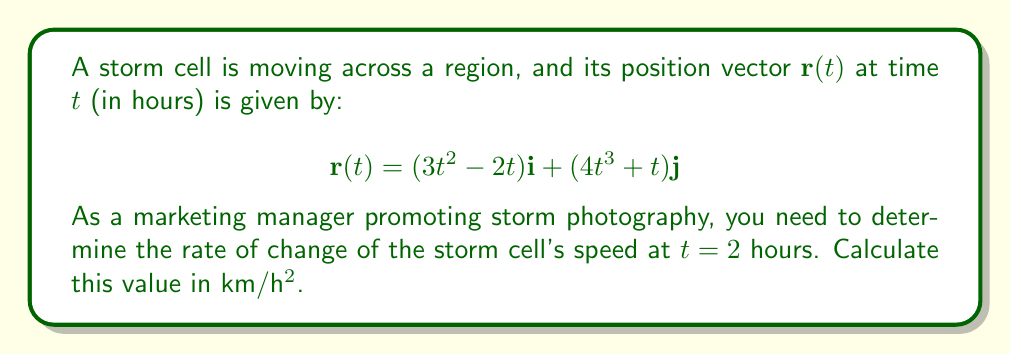Can you answer this question? To solve this problem, we'll follow these steps:

1) First, we need to find the velocity vector $\mathbf{v}(t)$ by differentiating $\mathbf{r}(t)$ with respect to $t$:

   $$\mathbf{v}(t) = \frac{d\mathbf{r}}{dt} = (6t - 2)\mathbf{i} + (12t^2 + 1)\mathbf{j}$$

2) The speed of the storm cell is the magnitude of the velocity vector:

   $$s(t) = \|\mathbf{v}(t)\| = \sqrt{(6t - 2)^2 + (12t^2 + 1)^2}$$

3) To find the rate of change of speed, we need to differentiate $s(t)$ with respect to $t$:

   $$\frac{ds}{dt} = \frac{d}{dt}\sqrt{(6t - 2)^2 + (12t^2 + 1)^2}$$

4) Using the chain rule:

   $$\frac{ds}{dt} = \frac{1}{2\sqrt{(6t - 2)^2 + (12t^2 + 1)^2}} \cdot \frac{d}{dt}[(6t - 2)^2 + (12t^2 + 1)^2]$$

5) Differentiating the inside:

   $$\frac{ds}{dt} = \frac{2(6t - 2)(6) + 2(12t^2 + 1)(24t)}{2\sqrt{(6t - 2)^2 + (12t^2 + 1)^2}}$$

6) Simplifying:

   $$\frac{ds}{dt} = \frac{12(6t - 2) + 48t(12t^2 + 1)}{2\sqrt{(6t - 2)^2 + (12t^2 + 1)^2}}$$

7) Now, we evaluate this at $t = 2$:

   $$\left.\frac{ds}{dt}\right|_{t=2} = \frac{12(10) + 48(2)(49)}{2\sqrt{10^2 + 49^2}}$$

8) Calculating:

   $$\left.\frac{ds}{dt}\right|_{t=2} = \frac{120 + 4704}{2\sqrt{100 + 2401}} = \frac{4824}{2\sqrt{2501}} \approx 48.21$$

Therefore, the rate of change of the storm cell's speed at $t = 2$ hours is approximately 48.21 km/h².
Answer: 48.21 km/h² 